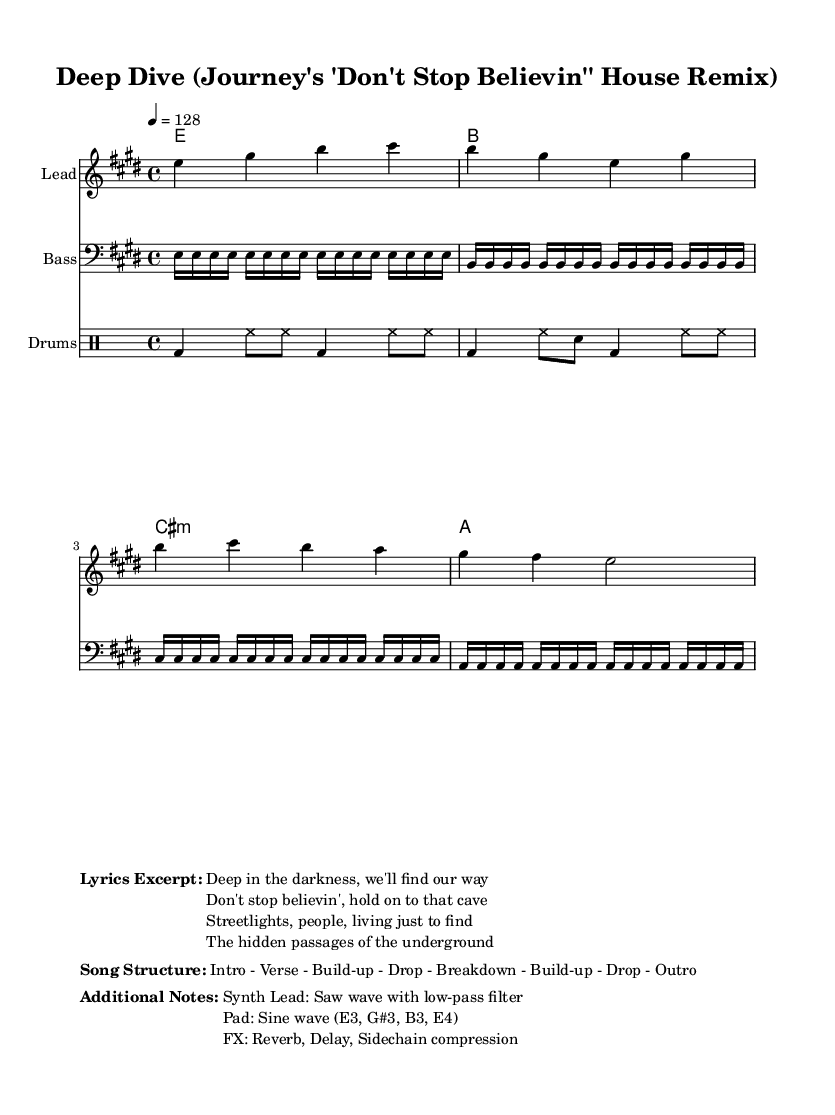What is the key signature of this music? The key signature is defined by the number of sharps or flats; in this case, it shows three sharps (F#, C#, and G#), which indicates that the piece is in E major.
Answer: E major What is the time signature of this music? The time signature is shown at the beginning of the sheet music and indicates how many beats are in each measure; here, it is 4/4, meaning there are four beats per measure.
Answer: 4/4 What is the tempo of this music? The tempo is specified by the number marked at the beginning of the score, indicating how fast the music is to be played; in this case, it indicates a tempo of 128 beats per minute.
Answer: 128 How many measures are in the melody section? To find the number of measures in the melody, we count each grouping separated by vertical bar lines in the melody staff; there are four distinct groupings, indicating four measures.
Answer: 4 What type of chord is used in the third harmony? Looking at the chord mode notation, the chords are laid out in the order of E, B, C# minor, and A; the third chord, C# minor, indicates a minor triad based on the root note C#.
Answer: C# minor What are the types of percussion used in the drum section? The drum notation outlines the patterns used; specifically, it shows bass drum (bd) and hi-hat (hh) notes, indicating typical elements of house music.
Answer: Bass drum and hi-hat What is the structure type of this music? The song structure is described clearly in the markup, outlining the flow of the song; the structure includes an intro, verse, build-up, drop, breakdown, and outro.
Answer: Intro - Verse - Build-up - Drop - Breakdown - Build-up - Drop - Outro 